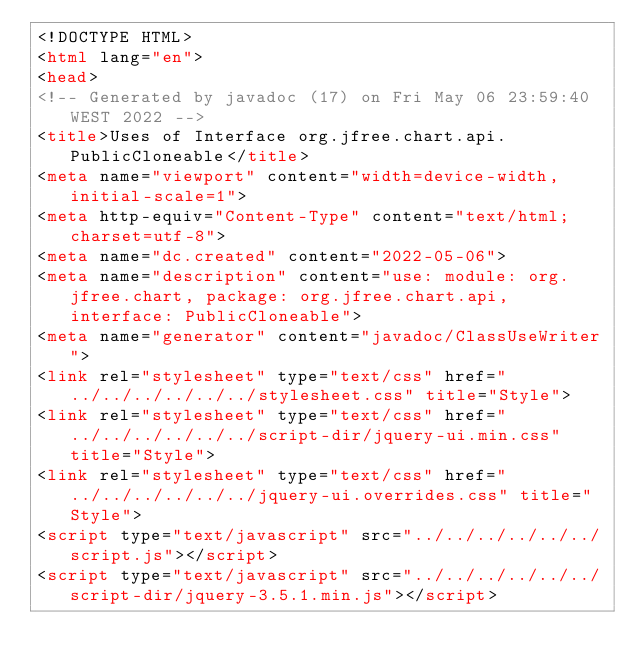<code> <loc_0><loc_0><loc_500><loc_500><_HTML_><!DOCTYPE HTML>
<html lang="en">
<head>
<!-- Generated by javadoc (17) on Fri May 06 23:59:40 WEST 2022 -->
<title>Uses of Interface org.jfree.chart.api.PublicCloneable</title>
<meta name="viewport" content="width=device-width, initial-scale=1">
<meta http-equiv="Content-Type" content="text/html; charset=utf-8">
<meta name="dc.created" content="2022-05-06">
<meta name="description" content="use: module: org.jfree.chart, package: org.jfree.chart.api, interface: PublicCloneable">
<meta name="generator" content="javadoc/ClassUseWriter">
<link rel="stylesheet" type="text/css" href="../../../../../../stylesheet.css" title="Style">
<link rel="stylesheet" type="text/css" href="../../../../../../script-dir/jquery-ui.min.css" title="Style">
<link rel="stylesheet" type="text/css" href="../../../../../../jquery-ui.overrides.css" title="Style">
<script type="text/javascript" src="../../../../../../script.js"></script>
<script type="text/javascript" src="../../../../../../script-dir/jquery-3.5.1.min.js"></script></code> 